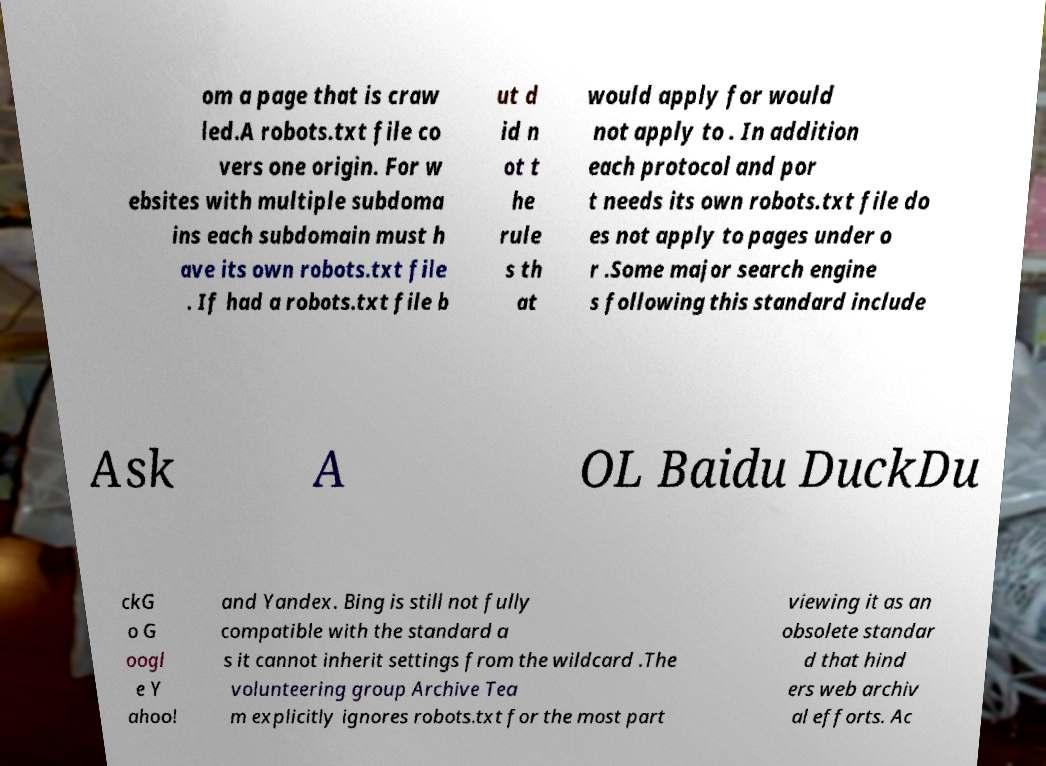Can you accurately transcribe the text from the provided image for me? om a page that is craw led.A robots.txt file co vers one origin. For w ebsites with multiple subdoma ins each subdomain must h ave its own robots.txt file . If had a robots.txt file b ut d id n ot t he rule s th at would apply for would not apply to . In addition each protocol and por t needs its own robots.txt file do es not apply to pages under o r .Some major search engine s following this standard include Ask A OL Baidu DuckDu ckG o G oogl e Y ahoo! and Yandex. Bing is still not fully compatible with the standard a s it cannot inherit settings from the wildcard .The volunteering group Archive Tea m explicitly ignores robots.txt for the most part viewing it as an obsolete standar d that hind ers web archiv al efforts. Ac 